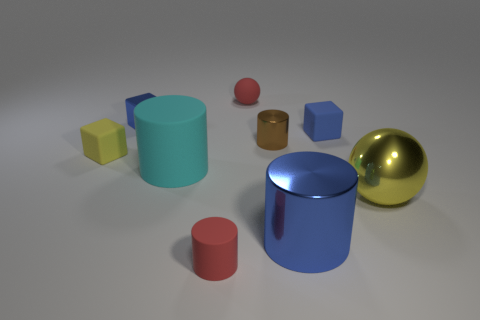The big object that is left of the small red rubber object that is in front of the big yellow metallic ball is what shape?
Offer a terse response. Cylinder. Is there anything else that has the same size as the rubber sphere?
Offer a terse response. Yes. The tiny rubber object to the right of the metallic thing in front of the metal thing that is to the right of the blue cylinder is what shape?
Offer a very short reply. Cube. How many things are either small rubber blocks to the right of the tiny brown metallic object or small red matte things that are to the left of the red matte sphere?
Offer a very short reply. 2. There is a brown cylinder; is its size the same as the blue shiny thing that is behind the large metal cylinder?
Make the answer very short. Yes. Are the tiny blue thing that is to the left of the big blue metallic thing and the tiny object that is in front of the yellow matte thing made of the same material?
Make the answer very short. No. Is the number of small red things that are to the left of the small red ball the same as the number of blue metallic cubes left of the big yellow metal object?
Your answer should be compact. Yes. What number of metallic spheres are the same color as the tiny rubber sphere?
Your response must be concise. 0. There is a thing that is the same color as the large sphere; what material is it?
Make the answer very short. Rubber. What number of rubber things are yellow cubes or tiny blue things?
Offer a very short reply. 2. 